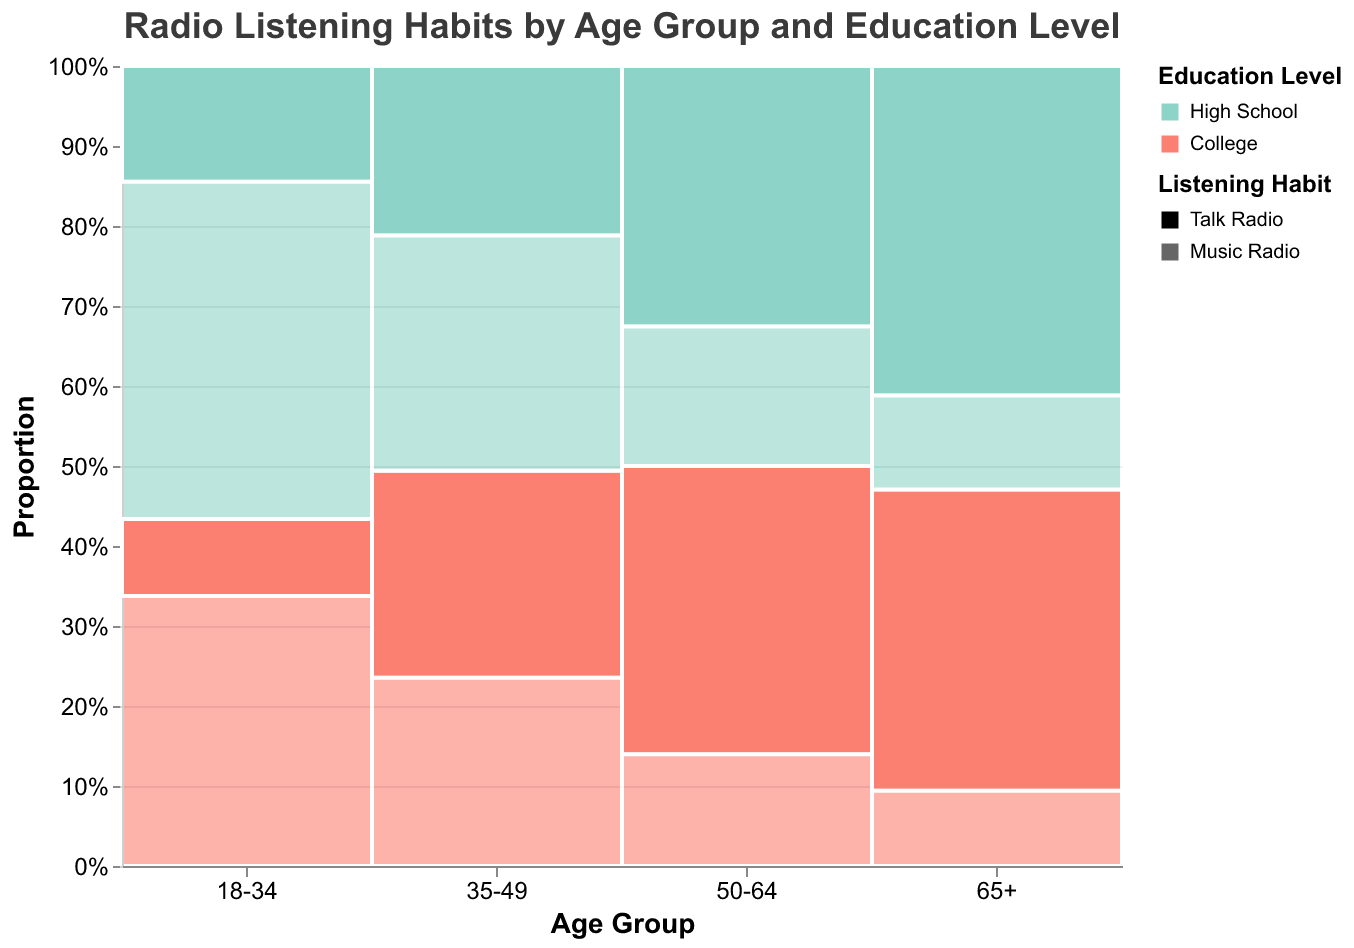What is the title of the figure? The title is often found at the top of the chart. This specific figure's title is "Radio Listening Habits by Age Group and Education Level."
Answer: Radio Listening Habits by Age Group and Education Level Which age group and education level have the highest proportion of Talk Radio listeners? By inspecting the height of the sections for each age group and education level, we see that the "65+" age group combined with "High School" education has the tallest section, indicating the highest proportion of Talk Radio listeners.
Answer: 65+ and High School What proportion of Music Radio listeners in the 18-34 age group have a college education? Looking at the 18-34 age group section, we locate the College education level within the Music Radio listeners. We compare the height of this section to the total height of Music Radio listeners in this age group. The section for College-educated Music Radio listeners is just over half of the entire Music Radio listeners' section.
Answer: Around 44% Which age group shows the highest total frequency of Talk Radio listeners irrespective of education level? We sum the frequencies of Talk Radio listeners (both High School and College) within each age group. The 65+ group has 350 (High School) + 320 (College) = 670 listeners, which is the highest compared to other age groups.
Answer: 65+ In the 50-64 age group, which education level has a higher proportion of Music Radio listeners? For the 50-64 age group, we compare the sections of High School and College within Music Radio listeners. The High School section is taller than the College section, indicating a higher proportion.
Answer: High School How does the proportion of Talk Radio listeners in the 35-49 age group with a college education compare to those with high school education? We look at the 35-49 age group and compare the height of the Talk Radio listeners' sections for College and High School education levels. The College section is taller, showing a higher proportion.
Answer: College is higher Which age and education combination has the lowest proportion of Music Radio listeners? By identifying the smallest section within the Music Radio listeners across all age groups and education levels, we find that the 65+ College education combination has the lowest proportion.
Answer: 65+ and College What is the overall trend of Talk Radio listening habits as age increases? Observing all age groups, we notice that the proportion of Talk Radio listeners increases as age increases. The bars for Talk Radio listening get progressively taller with each older age group.
Answer: Increasing trend How does the listening habit distribution differ between the youngest and oldest age groups for high school education? Compare the sections within the High School education levels for the 18-34 and 65+ age groups. The 18-34 age group has a higher proportion of Music Radio listeners, while the 65+ age group has a higher proportion of Talk Radio listeners.
Answer: Youngest prefers Music Radio, oldest prefers Talk Radio What is the total number of College-educated Talk Radio listeners across all age groups? Add up the frequencies of College-educated Talk Radio listeners: 80 (18-34) + 220 (35-49) + 310 (50-64) + 320 (65+). The total is 930.
Answer: 930 